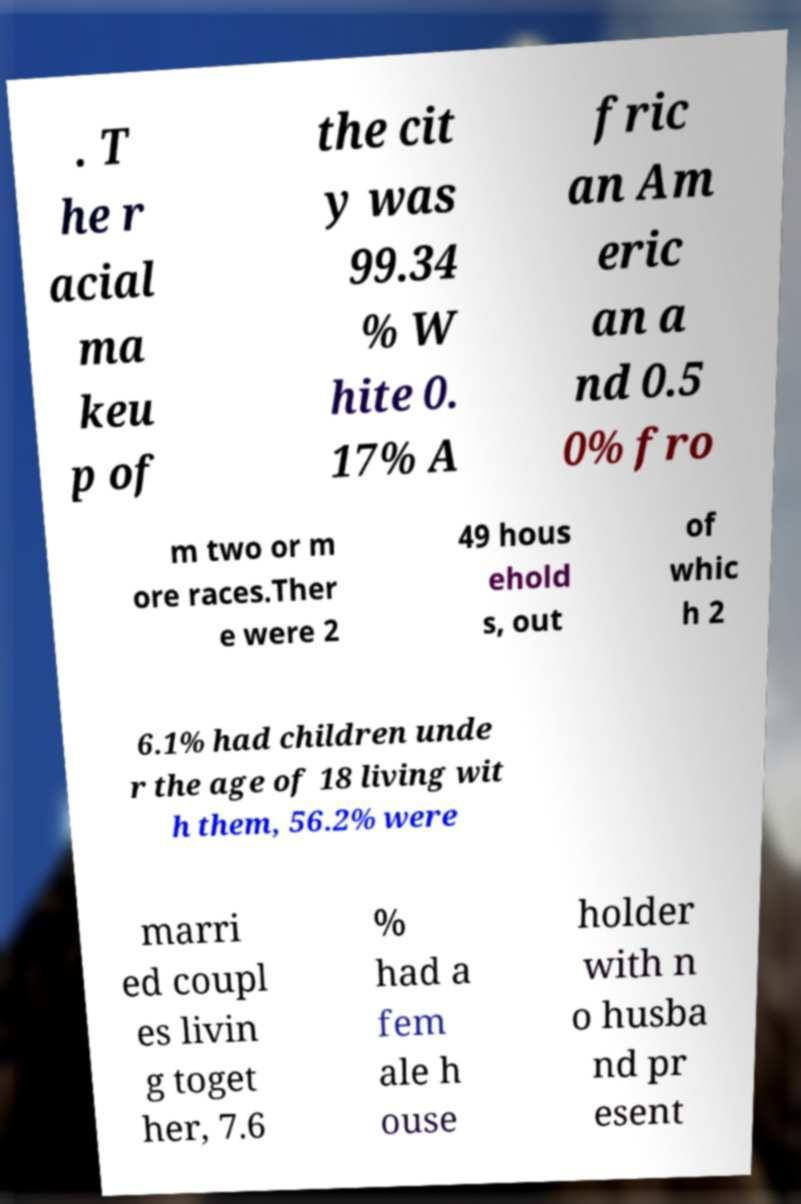What messages or text are displayed in this image? I need them in a readable, typed format. . T he r acial ma keu p of the cit y was 99.34 % W hite 0. 17% A fric an Am eric an a nd 0.5 0% fro m two or m ore races.Ther e were 2 49 hous ehold s, out of whic h 2 6.1% had children unde r the age of 18 living wit h them, 56.2% were marri ed coupl es livin g toget her, 7.6 % had a fem ale h ouse holder with n o husba nd pr esent 